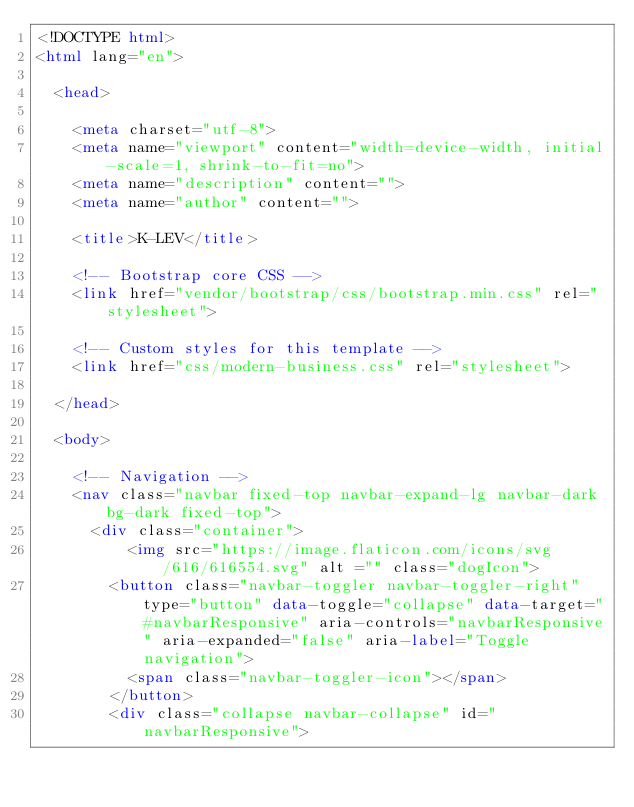<code> <loc_0><loc_0><loc_500><loc_500><_HTML_><!DOCTYPE html>
<html lang="en">

  <head>

    <meta charset="utf-8">
    <meta name="viewport" content="width=device-width, initial-scale=1, shrink-to-fit=no">
    <meta name="description" content="">
    <meta name="author" content="">

    <title>K-LEV</title>

    <!-- Bootstrap core CSS -->
    <link href="vendor/bootstrap/css/bootstrap.min.css" rel="stylesheet">

    <!-- Custom styles for this template -->
    <link href="css/modern-business.css" rel="stylesheet">

  </head>

  <body>

    <!-- Navigation -->
    <nav class="navbar fixed-top navbar-expand-lg navbar-dark bg-dark fixed-top">
      <div class="container">
          <img src="https://image.flaticon.com/icons/svg/616/616554.svg" alt ="" class="dogIcon">
        <button class="navbar-toggler navbar-toggler-right" type="button" data-toggle="collapse" data-target="#navbarResponsive" aria-controls="navbarResponsive" aria-expanded="false" aria-label="Toggle navigation">
          <span class="navbar-toggler-icon"></span>
        </button>
        <div class="collapse navbar-collapse" id="navbarResponsive"></code> 